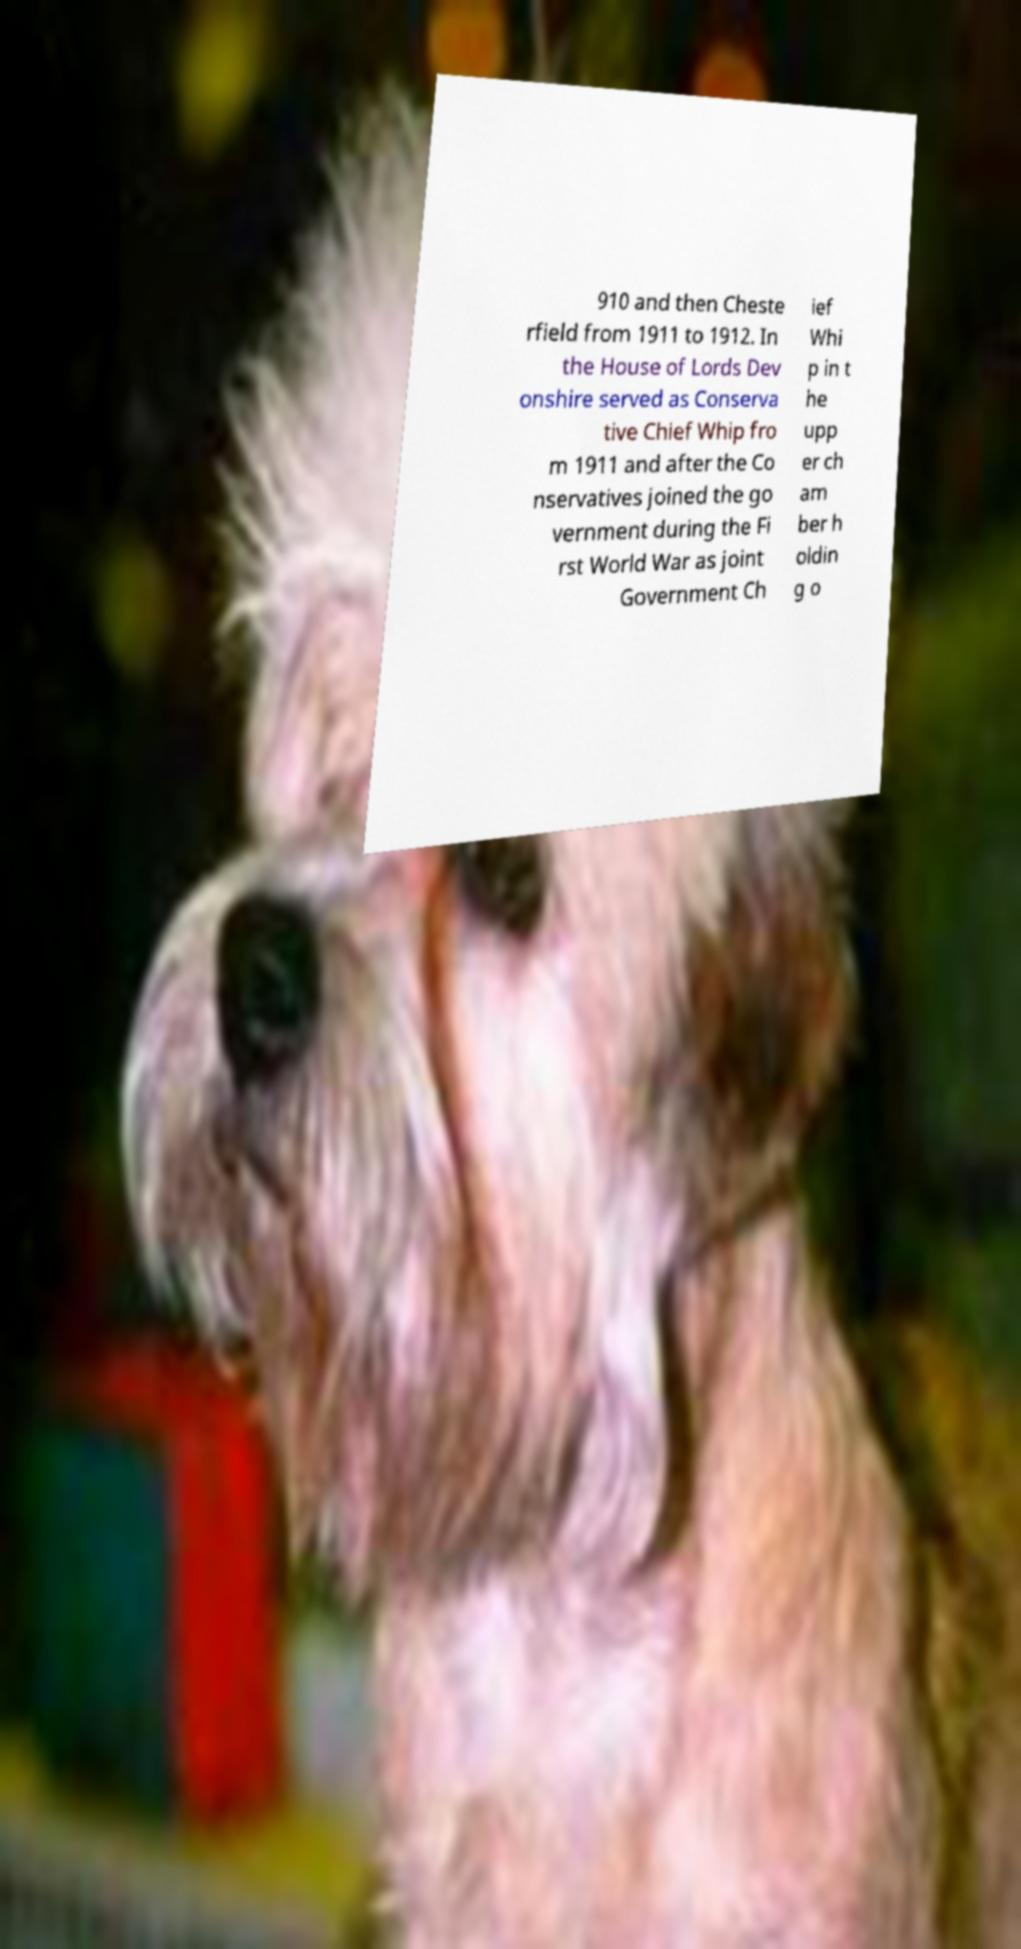Could you extract and type out the text from this image? 910 and then Cheste rfield from 1911 to 1912. In the House of Lords Dev onshire served as Conserva tive Chief Whip fro m 1911 and after the Co nservatives joined the go vernment during the Fi rst World War as joint Government Ch ief Whi p in t he upp er ch am ber h oldin g o 